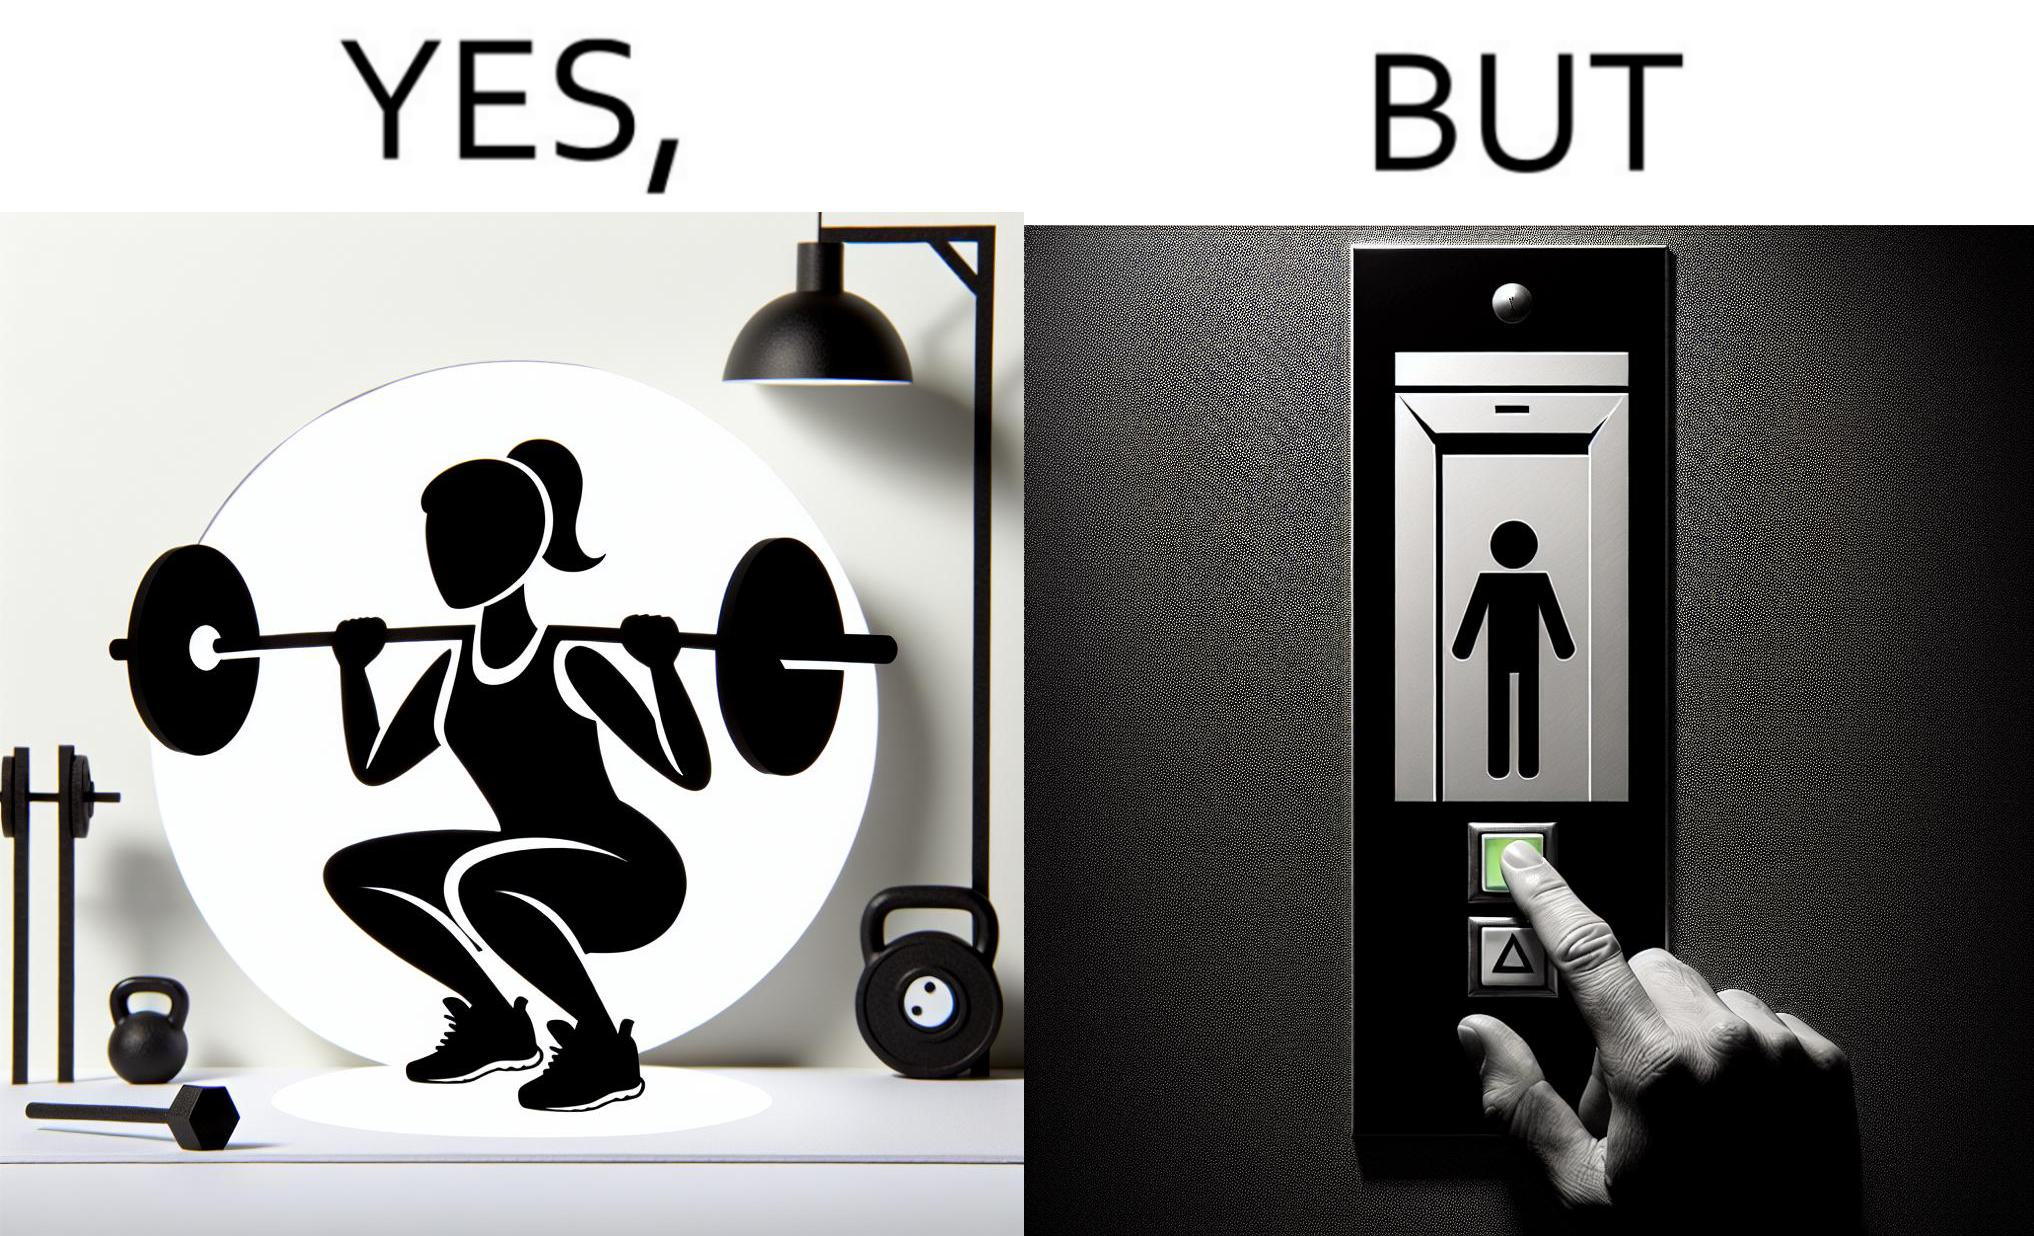Explain the humor or irony in this image. The image is satirical because it shows that while people do various kinds of exercises and go to gym to stay fit, they avoid doing simplest of physical tasks like using stairs instead of elevators to get to even the first or the second floor of a building. 